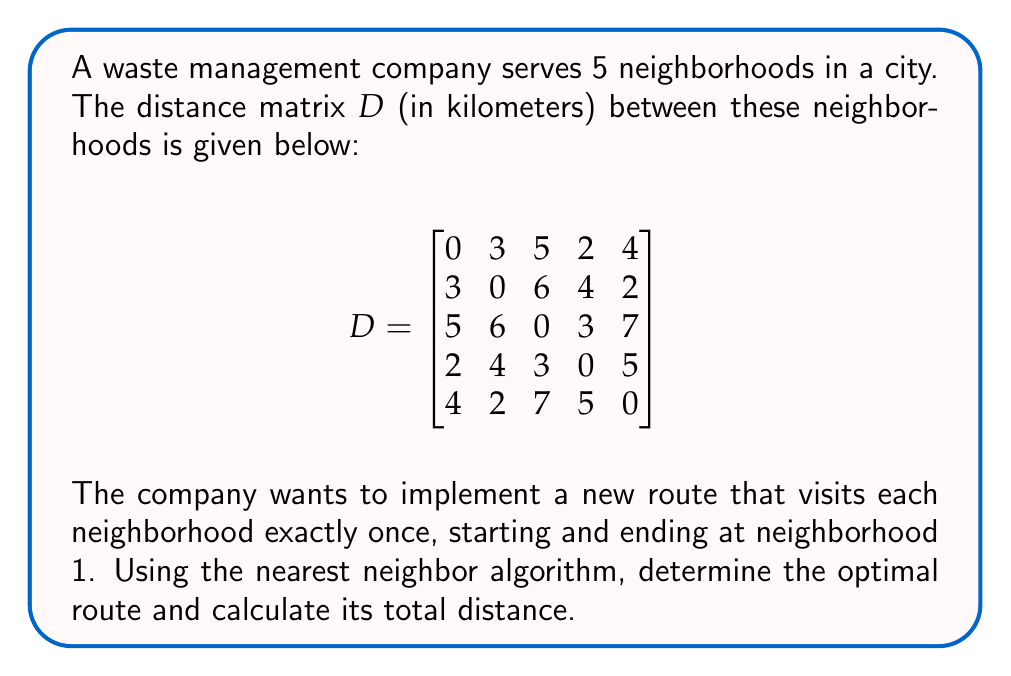Could you help me with this problem? Let's solve this step-by-step using the nearest neighbor algorithm:

1) Start at neighborhood 1.

2) Find the nearest unvisited neighborhood:
   - From row 1 of matrix $D$, the smallest non-zero value is 2 (to neighborhood 4).
   
3) Move to neighborhood 4.

4) From neighborhood 4, find the nearest unvisited neighborhood:
   - From row 4 of matrix $D$, excluding already visited neighborhoods, the smallest value is 3 (to neighborhood 3).

5) Move to neighborhood 3.

6) From neighborhood 3, find the nearest unvisited neighborhood:
   - From row 3 of matrix $D$, excluding visited neighborhoods, the smallest value is 6 (to neighborhood 2).

7) Move to neighborhood 2.

8) The only unvisited neighborhood is 5, so move there.

9) Finally, return to neighborhood 1.

The route is: 1 → 4 → 3 → 2 → 5 → 1

To calculate the total distance:
$$\text{Total Distance} = D_{1,4} + D_{4,3} + D_{3,2} + D_{2,5} + D_{5,1}$$
$$= 2 + 3 + 6 + 2 + 4 = 17 \text{ km}$$
Answer: Route: 1 → 4 → 3 → 2 → 5 → 1; Total distance: 17 km 